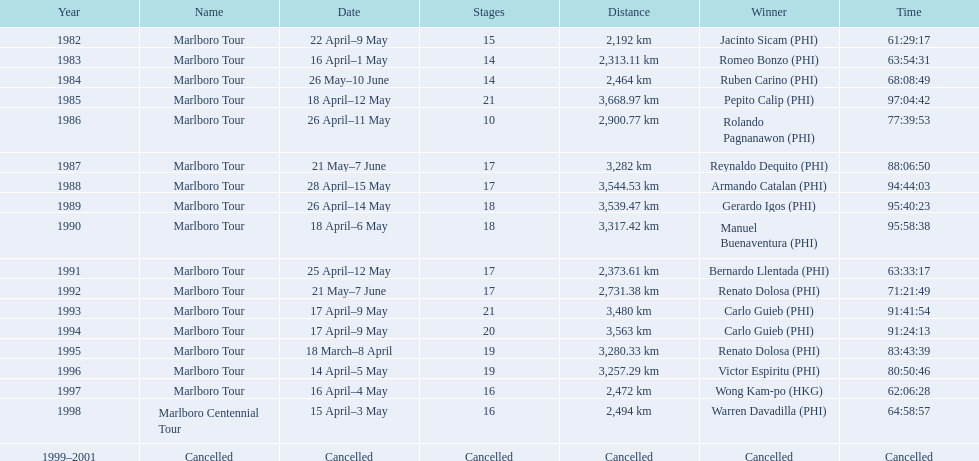Who is listed before wong kam-po? Victor Espiritu (PHI). Parse the table in full. {'header': ['Year', 'Name', 'Date', 'Stages', 'Distance', 'Winner', 'Time'], 'rows': [['1982', 'Marlboro Tour', '22 April–9 May', '15', '2,192\xa0km', 'Jacinto Sicam\xa0(PHI)', '61:29:17'], ['1983', 'Marlboro Tour', '16 April–1 May', '14', '2,313.11\xa0km', 'Romeo Bonzo\xa0(PHI)', '63:54:31'], ['1984', 'Marlboro Tour', '26 May–10 June', '14', '2,464\xa0km', 'Ruben Carino\xa0(PHI)', '68:08:49'], ['1985', 'Marlboro Tour', '18 April–12 May', '21', '3,668.97\xa0km', 'Pepito Calip\xa0(PHI)', '97:04:42'], ['1986', 'Marlboro Tour', '26 April–11 May', '10', '2,900.77\xa0km', 'Rolando Pagnanawon\xa0(PHI)', '77:39:53'], ['1987', 'Marlboro Tour', '21 May–7 June', '17', '3,282\xa0km', 'Reynaldo Dequito\xa0(PHI)', '88:06:50'], ['1988', 'Marlboro Tour', '28 April–15 May', '17', '3,544.53\xa0km', 'Armando Catalan\xa0(PHI)', '94:44:03'], ['1989', 'Marlboro Tour', '26 April–14 May', '18', '3,539.47\xa0km', 'Gerardo Igos\xa0(PHI)', '95:40:23'], ['1990', 'Marlboro Tour', '18 April–6 May', '18', '3,317.42\xa0km', 'Manuel Buenaventura\xa0(PHI)', '95:58:38'], ['1991', 'Marlboro Tour', '25 April–12 May', '17', '2,373.61\xa0km', 'Bernardo Llentada\xa0(PHI)', '63:33:17'], ['1992', 'Marlboro Tour', '21 May–7 June', '17', '2,731.38\xa0km', 'Renato Dolosa\xa0(PHI)', '71:21:49'], ['1993', 'Marlboro Tour', '17 April–9 May', '21', '3,480\xa0km', 'Carlo Guieb\xa0(PHI)', '91:41:54'], ['1994', 'Marlboro Tour', '17 April–9 May', '20', '3,563\xa0km', 'Carlo Guieb\xa0(PHI)', '91:24:13'], ['1995', 'Marlboro Tour', '18 March–8 April', '19', '3,280.33\xa0km', 'Renato Dolosa\xa0(PHI)', '83:43:39'], ['1996', 'Marlboro Tour', '14 April–5 May', '19', '3,257.29\xa0km', 'Victor Espiritu\xa0(PHI)', '80:50:46'], ['1997', 'Marlboro Tour', '16 April–4 May', '16', '2,472\xa0km', 'Wong Kam-po\xa0(HKG)', '62:06:28'], ['1998', 'Marlboro Centennial Tour', '15 April–3 May', '16', '2,494\xa0km', 'Warren Davadilla\xa0(PHI)', '64:58:57'], ['1999–2001', 'Cancelled', 'Cancelled', 'Cancelled', 'Cancelled', 'Cancelled', 'Cancelled']]} 